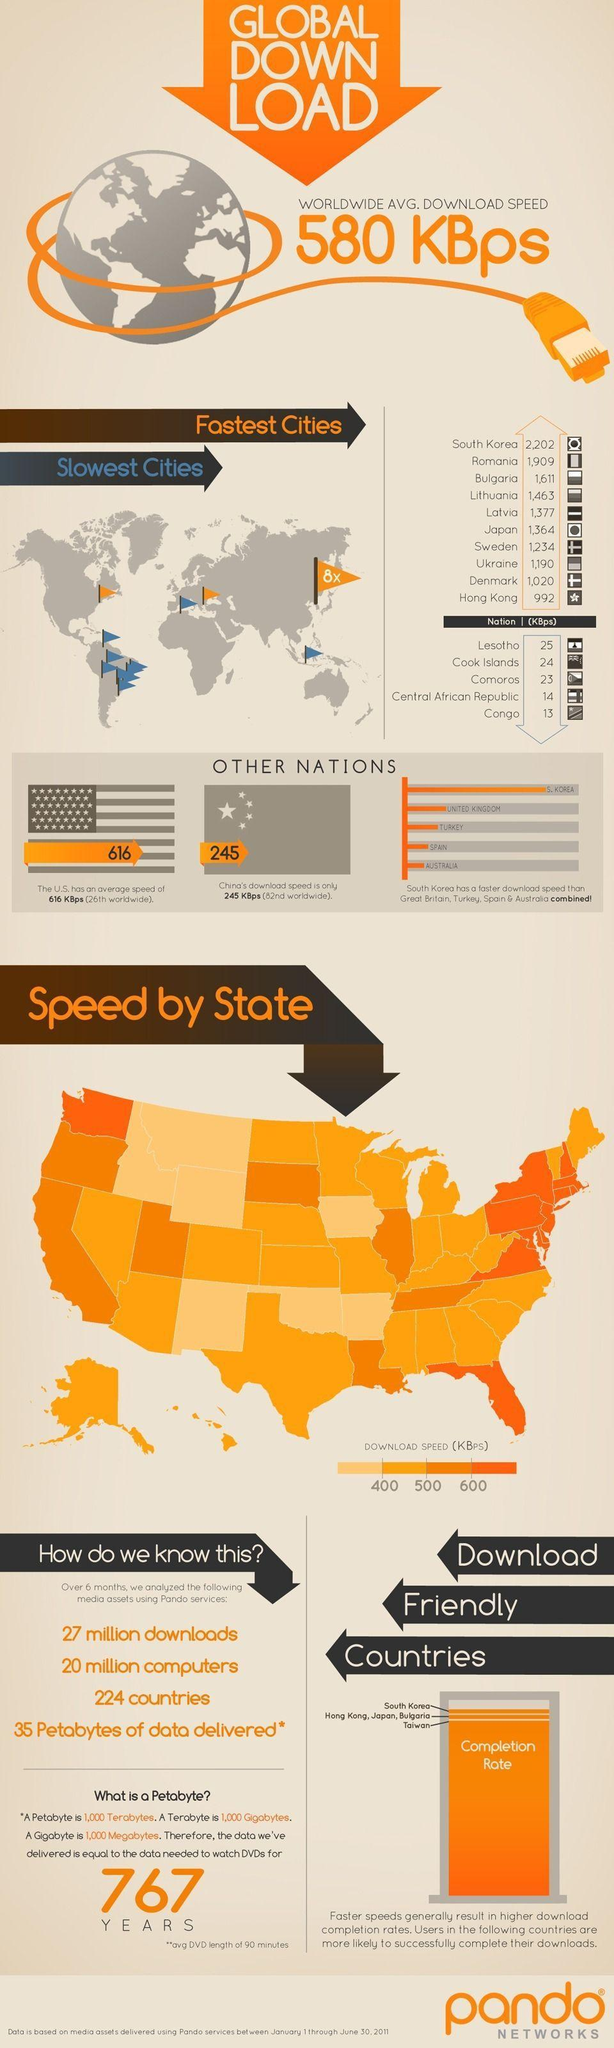Which country has eight times more internet speed than the rest of the world ?
Answer the question with a short phrase. South Korea How many states in the US have less than 400 KBps download speed? 7 Which countries have less than 15 KBps speed? Central African Republic, Congo 